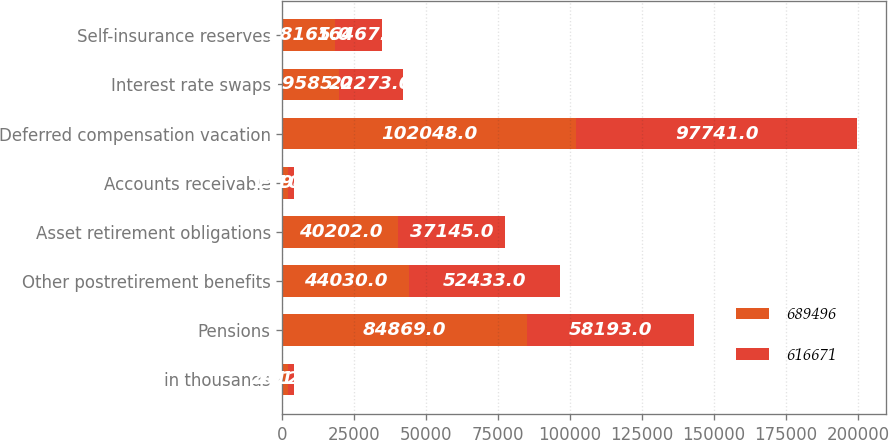Convert chart to OTSL. <chart><loc_0><loc_0><loc_500><loc_500><stacked_bar_chart><ecel><fcel>in thousands<fcel>Pensions<fcel>Other postretirement benefits<fcel>Asset retirement obligations<fcel>Accounts receivable<fcel>Deferred compensation vacation<fcel>Interest rate swaps<fcel>Self-insurance reserves<nl><fcel>689496<fcel>2012<fcel>84869<fcel>44030<fcel>40202<fcel>1910<fcel>102048<fcel>19585<fcel>18165<nl><fcel>616671<fcel>2011<fcel>58193<fcel>52433<fcel>37145<fcel>2194<fcel>97741<fcel>22273<fcel>16467<nl></chart> 